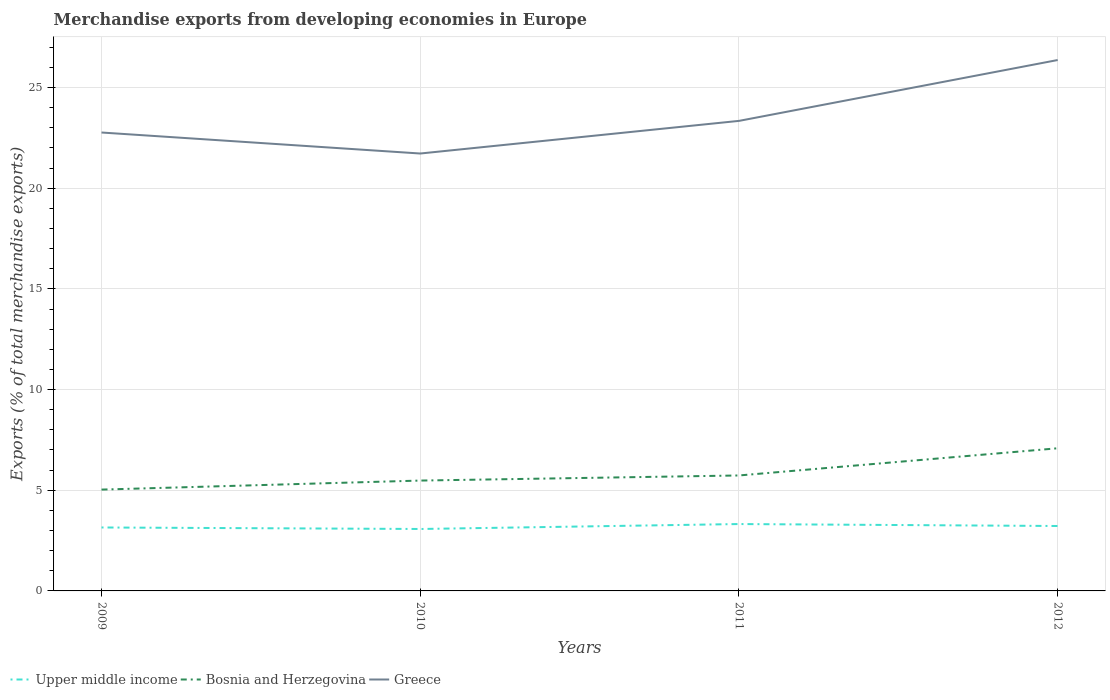How many different coloured lines are there?
Provide a short and direct response. 3. Is the number of lines equal to the number of legend labels?
Ensure brevity in your answer.  Yes. Across all years, what is the maximum percentage of total merchandise exports in Upper middle income?
Offer a very short reply. 3.08. In which year was the percentage of total merchandise exports in Upper middle income maximum?
Ensure brevity in your answer.  2010. What is the total percentage of total merchandise exports in Greece in the graph?
Provide a short and direct response. -3.6. What is the difference between the highest and the second highest percentage of total merchandise exports in Bosnia and Herzegovina?
Give a very brief answer. 2.05. Is the percentage of total merchandise exports in Upper middle income strictly greater than the percentage of total merchandise exports in Greece over the years?
Your answer should be very brief. Yes. How many lines are there?
Your response must be concise. 3. Are the values on the major ticks of Y-axis written in scientific E-notation?
Your response must be concise. No. Does the graph contain any zero values?
Your answer should be very brief. No. Where does the legend appear in the graph?
Keep it short and to the point. Bottom left. How many legend labels are there?
Provide a short and direct response. 3. What is the title of the graph?
Your answer should be compact. Merchandise exports from developing economies in Europe. What is the label or title of the Y-axis?
Make the answer very short. Exports (% of total merchandise exports). What is the Exports (% of total merchandise exports) of Upper middle income in 2009?
Provide a short and direct response. 3.15. What is the Exports (% of total merchandise exports) of Bosnia and Herzegovina in 2009?
Your response must be concise. 5.03. What is the Exports (% of total merchandise exports) of Greece in 2009?
Your answer should be compact. 22.77. What is the Exports (% of total merchandise exports) in Upper middle income in 2010?
Your response must be concise. 3.08. What is the Exports (% of total merchandise exports) in Bosnia and Herzegovina in 2010?
Provide a short and direct response. 5.48. What is the Exports (% of total merchandise exports) in Greece in 2010?
Provide a succinct answer. 21.72. What is the Exports (% of total merchandise exports) in Upper middle income in 2011?
Provide a succinct answer. 3.32. What is the Exports (% of total merchandise exports) in Bosnia and Herzegovina in 2011?
Keep it short and to the point. 5.73. What is the Exports (% of total merchandise exports) in Greece in 2011?
Make the answer very short. 23.34. What is the Exports (% of total merchandise exports) in Upper middle income in 2012?
Offer a very short reply. 3.22. What is the Exports (% of total merchandise exports) of Bosnia and Herzegovina in 2012?
Your answer should be compact. 7.08. What is the Exports (% of total merchandise exports) in Greece in 2012?
Keep it short and to the point. 26.36. Across all years, what is the maximum Exports (% of total merchandise exports) of Upper middle income?
Your response must be concise. 3.32. Across all years, what is the maximum Exports (% of total merchandise exports) of Bosnia and Herzegovina?
Your response must be concise. 7.08. Across all years, what is the maximum Exports (% of total merchandise exports) in Greece?
Give a very brief answer. 26.36. Across all years, what is the minimum Exports (% of total merchandise exports) of Upper middle income?
Keep it short and to the point. 3.08. Across all years, what is the minimum Exports (% of total merchandise exports) of Bosnia and Herzegovina?
Give a very brief answer. 5.03. Across all years, what is the minimum Exports (% of total merchandise exports) in Greece?
Your answer should be very brief. 21.72. What is the total Exports (% of total merchandise exports) of Upper middle income in the graph?
Your answer should be very brief. 12.77. What is the total Exports (% of total merchandise exports) of Bosnia and Herzegovina in the graph?
Give a very brief answer. 23.33. What is the total Exports (% of total merchandise exports) in Greece in the graph?
Your answer should be very brief. 94.19. What is the difference between the Exports (% of total merchandise exports) of Upper middle income in 2009 and that in 2010?
Keep it short and to the point. 0.08. What is the difference between the Exports (% of total merchandise exports) of Bosnia and Herzegovina in 2009 and that in 2010?
Provide a succinct answer. -0.45. What is the difference between the Exports (% of total merchandise exports) in Greece in 2009 and that in 2010?
Give a very brief answer. 1.04. What is the difference between the Exports (% of total merchandise exports) of Upper middle income in 2009 and that in 2011?
Offer a very short reply. -0.17. What is the difference between the Exports (% of total merchandise exports) of Bosnia and Herzegovina in 2009 and that in 2011?
Provide a short and direct response. -0.7. What is the difference between the Exports (% of total merchandise exports) in Greece in 2009 and that in 2011?
Ensure brevity in your answer.  -0.58. What is the difference between the Exports (% of total merchandise exports) in Upper middle income in 2009 and that in 2012?
Provide a short and direct response. -0.07. What is the difference between the Exports (% of total merchandise exports) of Bosnia and Herzegovina in 2009 and that in 2012?
Make the answer very short. -2.05. What is the difference between the Exports (% of total merchandise exports) of Greece in 2009 and that in 2012?
Give a very brief answer. -3.6. What is the difference between the Exports (% of total merchandise exports) in Upper middle income in 2010 and that in 2011?
Your answer should be compact. -0.25. What is the difference between the Exports (% of total merchandise exports) of Bosnia and Herzegovina in 2010 and that in 2011?
Your response must be concise. -0.25. What is the difference between the Exports (% of total merchandise exports) of Greece in 2010 and that in 2011?
Your answer should be compact. -1.62. What is the difference between the Exports (% of total merchandise exports) of Upper middle income in 2010 and that in 2012?
Ensure brevity in your answer.  -0.15. What is the difference between the Exports (% of total merchandise exports) of Bosnia and Herzegovina in 2010 and that in 2012?
Your response must be concise. -1.6. What is the difference between the Exports (% of total merchandise exports) of Greece in 2010 and that in 2012?
Ensure brevity in your answer.  -4.64. What is the difference between the Exports (% of total merchandise exports) of Upper middle income in 2011 and that in 2012?
Make the answer very short. 0.1. What is the difference between the Exports (% of total merchandise exports) of Bosnia and Herzegovina in 2011 and that in 2012?
Provide a short and direct response. -1.35. What is the difference between the Exports (% of total merchandise exports) of Greece in 2011 and that in 2012?
Make the answer very short. -3.02. What is the difference between the Exports (% of total merchandise exports) of Upper middle income in 2009 and the Exports (% of total merchandise exports) of Bosnia and Herzegovina in 2010?
Provide a succinct answer. -2.33. What is the difference between the Exports (% of total merchandise exports) in Upper middle income in 2009 and the Exports (% of total merchandise exports) in Greece in 2010?
Provide a succinct answer. -18.57. What is the difference between the Exports (% of total merchandise exports) in Bosnia and Herzegovina in 2009 and the Exports (% of total merchandise exports) in Greece in 2010?
Provide a short and direct response. -16.69. What is the difference between the Exports (% of total merchandise exports) in Upper middle income in 2009 and the Exports (% of total merchandise exports) in Bosnia and Herzegovina in 2011?
Give a very brief answer. -2.58. What is the difference between the Exports (% of total merchandise exports) in Upper middle income in 2009 and the Exports (% of total merchandise exports) in Greece in 2011?
Make the answer very short. -20.19. What is the difference between the Exports (% of total merchandise exports) in Bosnia and Herzegovina in 2009 and the Exports (% of total merchandise exports) in Greece in 2011?
Your answer should be very brief. -18.31. What is the difference between the Exports (% of total merchandise exports) in Upper middle income in 2009 and the Exports (% of total merchandise exports) in Bosnia and Herzegovina in 2012?
Offer a terse response. -3.93. What is the difference between the Exports (% of total merchandise exports) of Upper middle income in 2009 and the Exports (% of total merchandise exports) of Greece in 2012?
Your answer should be very brief. -23.21. What is the difference between the Exports (% of total merchandise exports) in Bosnia and Herzegovina in 2009 and the Exports (% of total merchandise exports) in Greece in 2012?
Offer a very short reply. -21.33. What is the difference between the Exports (% of total merchandise exports) in Upper middle income in 2010 and the Exports (% of total merchandise exports) in Bosnia and Herzegovina in 2011?
Offer a terse response. -2.66. What is the difference between the Exports (% of total merchandise exports) in Upper middle income in 2010 and the Exports (% of total merchandise exports) in Greece in 2011?
Give a very brief answer. -20.27. What is the difference between the Exports (% of total merchandise exports) of Bosnia and Herzegovina in 2010 and the Exports (% of total merchandise exports) of Greece in 2011?
Your answer should be very brief. -17.86. What is the difference between the Exports (% of total merchandise exports) in Upper middle income in 2010 and the Exports (% of total merchandise exports) in Bosnia and Herzegovina in 2012?
Offer a terse response. -4.01. What is the difference between the Exports (% of total merchandise exports) in Upper middle income in 2010 and the Exports (% of total merchandise exports) in Greece in 2012?
Ensure brevity in your answer.  -23.29. What is the difference between the Exports (% of total merchandise exports) of Bosnia and Herzegovina in 2010 and the Exports (% of total merchandise exports) of Greece in 2012?
Provide a short and direct response. -20.88. What is the difference between the Exports (% of total merchandise exports) in Upper middle income in 2011 and the Exports (% of total merchandise exports) in Bosnia and Herzegovina in 2012?
Your answer should be compact. -3.76. What is the difference between the Exports (% of total merchandise exports) in Upper middle income in 2011 and the Exports (% of total merchandise exports) in Greece in 2012?
Your answer should be compact. -23.04. What is the difference between the Exports (% of total merchandise exports) of Bosnia and Herzegovina in 2011 and the Exports (% of total merchandise exports) of Greece in 2012?
Ensure brevity in your answer.  -20.63. What is the average Exports (% of total merchandise exports) in Upper middle income per year?
Give a very brief answer. 3.19. What is the average Exports (% of total merchandise exports) in Bosnia and Herzegovina per year?
Give a very brief answer. 5.83. What is the average Exports (% of total merchandise exports) of Greece per year?
Provide a succinct answer. 23.55. In the year 2009, what is the difference between the Exports (% of total merchandise exports) in Upper middle income and Exports (% of total merchandise exports) in Bosnia and Herzegovina?
Make the answer very short. -1.88. In the year 2009, what is the difference between the Exports (% of total merchandise exports) of Upper middle income and Exports (% of total merchandise exports) of Greece?
Your response must be concise. -19.61. In the year 2009, what is the difference between the Exports (% of total merchandise exports) in Bosnia and Herzegovina and Exports (% of total merchandise exports) in Greece?
Offer a very short reply. -17.73. In the year 2010, what is the difference between the Exports (% of total merchandise exports) in Upper middle income and Exports (% of total merchandise exports) in Bosnia and Herzegovina?
Give a very brief answer. -2.4. In the year 2010, what is the difference between the Exports (% of total merchandise exports) in Upper middle income and Exports (% of total merchandise exports) in Greece?
Offer a very short reply. -18.65. In the year 2010, what is the difference between the Exports (% of total merchandise exports) of Bosnia and Herzegovina and Exports (% of total merchandise exports) of Greece?
Give a very brief answer. -16.24. In the year 2011, what is the difference between the Exports (% of total merchandise exports) of Upper middle income and Exports (% of total merchandise exports) of Bosnia and Herzegovina?
Give a very brief answer. -2.41. In the year 2011, what is the difference between the Exports (% of total merchandise exports) in Upper middle income and Exports (% of total merchandise exports) in Greece?
Provide a short and direct response. -20.02. In the year 2011, what is the difference between the Exports (% of total merchandise exports) of Bosnia and Herzegovina and Exports (% of total merchandise exports) of Greece?
Provide a succinct answer. -17.61. In the year 2012, what is the difference between the Exports (% of total merchandise exports) in Upper middle income and Exports (% of total merchandise exports) in Bosnia and Herzegovina?
Give a very brief answer. -3.86. In the year 2012, what is the difference between the Exports (% of total merchandise exports) in Upper middle income and Exports (% of total merchandise exports) in Greece?
Your response must be concise. -23.14. In the year 2012, what is the difference between the Exports (% of total merchandise exports) in Bosnia and Herzegovina and Exports (% of total merchandise exports) in Greece?
Provide a succinct answer. -19.28. What is the ratio of the Exports (% of total merchandise exports) in Upper middle income in 2009 to that in 2010?
Give a very brief answer. 1.02. What is the ratio of the Exports (% of total merchandise exports) of Bosnia and Herzegovina in 2009 to that in 2010?
Offer a terse response. 0.92. What is the ratio of the Exports (% of total merchandise exports) in Greece in 2009 to that in 2010?
Your answer should be compact. 1.05. What is the ratio of the Exports (% of total merchandise exports) of Upper middle income in 2009 to that in 2011?
Your response must be concise. 0.95. What is the ratio of the Exports (% of total merchandise exports) in Bosnia and Herzegovina in 2009 to that in 2011?
Offer a very short reply. 0.88. What is the ratio of the Exports (% of total merchandise exports) in Greece in 2009 to that in 2011?
Your answer should be compact. 0.98. What is the ratio of the Exports (% of total merchandise exports) in Upper middle income in 2009 to that in 2012?
Your response must be concise. 0.98. What is the ratio of the Exports (% of total merchandise exports) of Bosnia and Herzegovina in 2009 to that in 2012?
Your answer should be very brief. 0.71. What is the ratio of the Exports (% of total merchandise exports) of Greece in 2009 to that in 2012?
Offer a very short reply. 0.86. What is the ratio of the Exports (% of total merchandise exports) of Upper middle income in 2010 to that in 2011?
Your answer should be very brief. 0.93. What is the ratio of the Exports (% of total merchandise exports) in Bosnia and Herzegovina in 2010 to that in 2011?
Offer a very short reply. 0.96. What is the ratio of the Exports (% of total merchandise exports) in Greece in 2010 to that in 2011?
Your answer should be very brief. 0.93. What is the ratio of the Exports (% of total merchandise exports) of Upper middle income in 2010 to that in 2012?
Give a very brief answer. 0.95. What is the ratio of the Exports (% of total merchandise exports) of Bosnia and Herzegovina in 2010 to that in 2012?
Keep it short and to the point. 0.77. What is the ratio of the Exports (% of total merchandise exports) in Greece in 2010 to that in 2012?
Keep it short and to the point. 0.82. What is the ratio of the Exports (% of total merchandise exports) of Upper middle income in 2011 to that in 2012?
Your answer should be very brief. 1.03. What is the ratio of the Exports (% of total merchandise exports) of Bosnia and Herzegovina in 2011 to that in 2012?
Keep it short and to the point. 0.81. What is the ratio of the Exports (% of total merchandise exports) in Greece in 2011 to that in 2012?
Your answer should be compact. 0.89. What is the difference between the highest and the second highest Exports (% of total merchandise exports) of Upper middle income?
Your response must be concise. 0.1. What is the difference between the highest and the second highest Exports (% of total merchandise exports) of Bosnia and Herzegovina?
Your answer should be compact. 1.35. What is the difference between the highest and the second highest Exports (% of total merchandise exports) of Greece?
Offer a very short reply. 3.02. What is the difference between the highest and the lowest Exports (% of total merchandise exports) of Upper middle income?
Your response must be concise. 0.25. What is the difference between the highest and the lowest Exports (% of total merchandise exports) in Bosnia and Herzegovina?
Ensure brevity in your answer.  2.05. What is the difference between the highest and the lowest Exports (% of total merchandise exports) in Greece?
Make the answer very short. 4.64. 